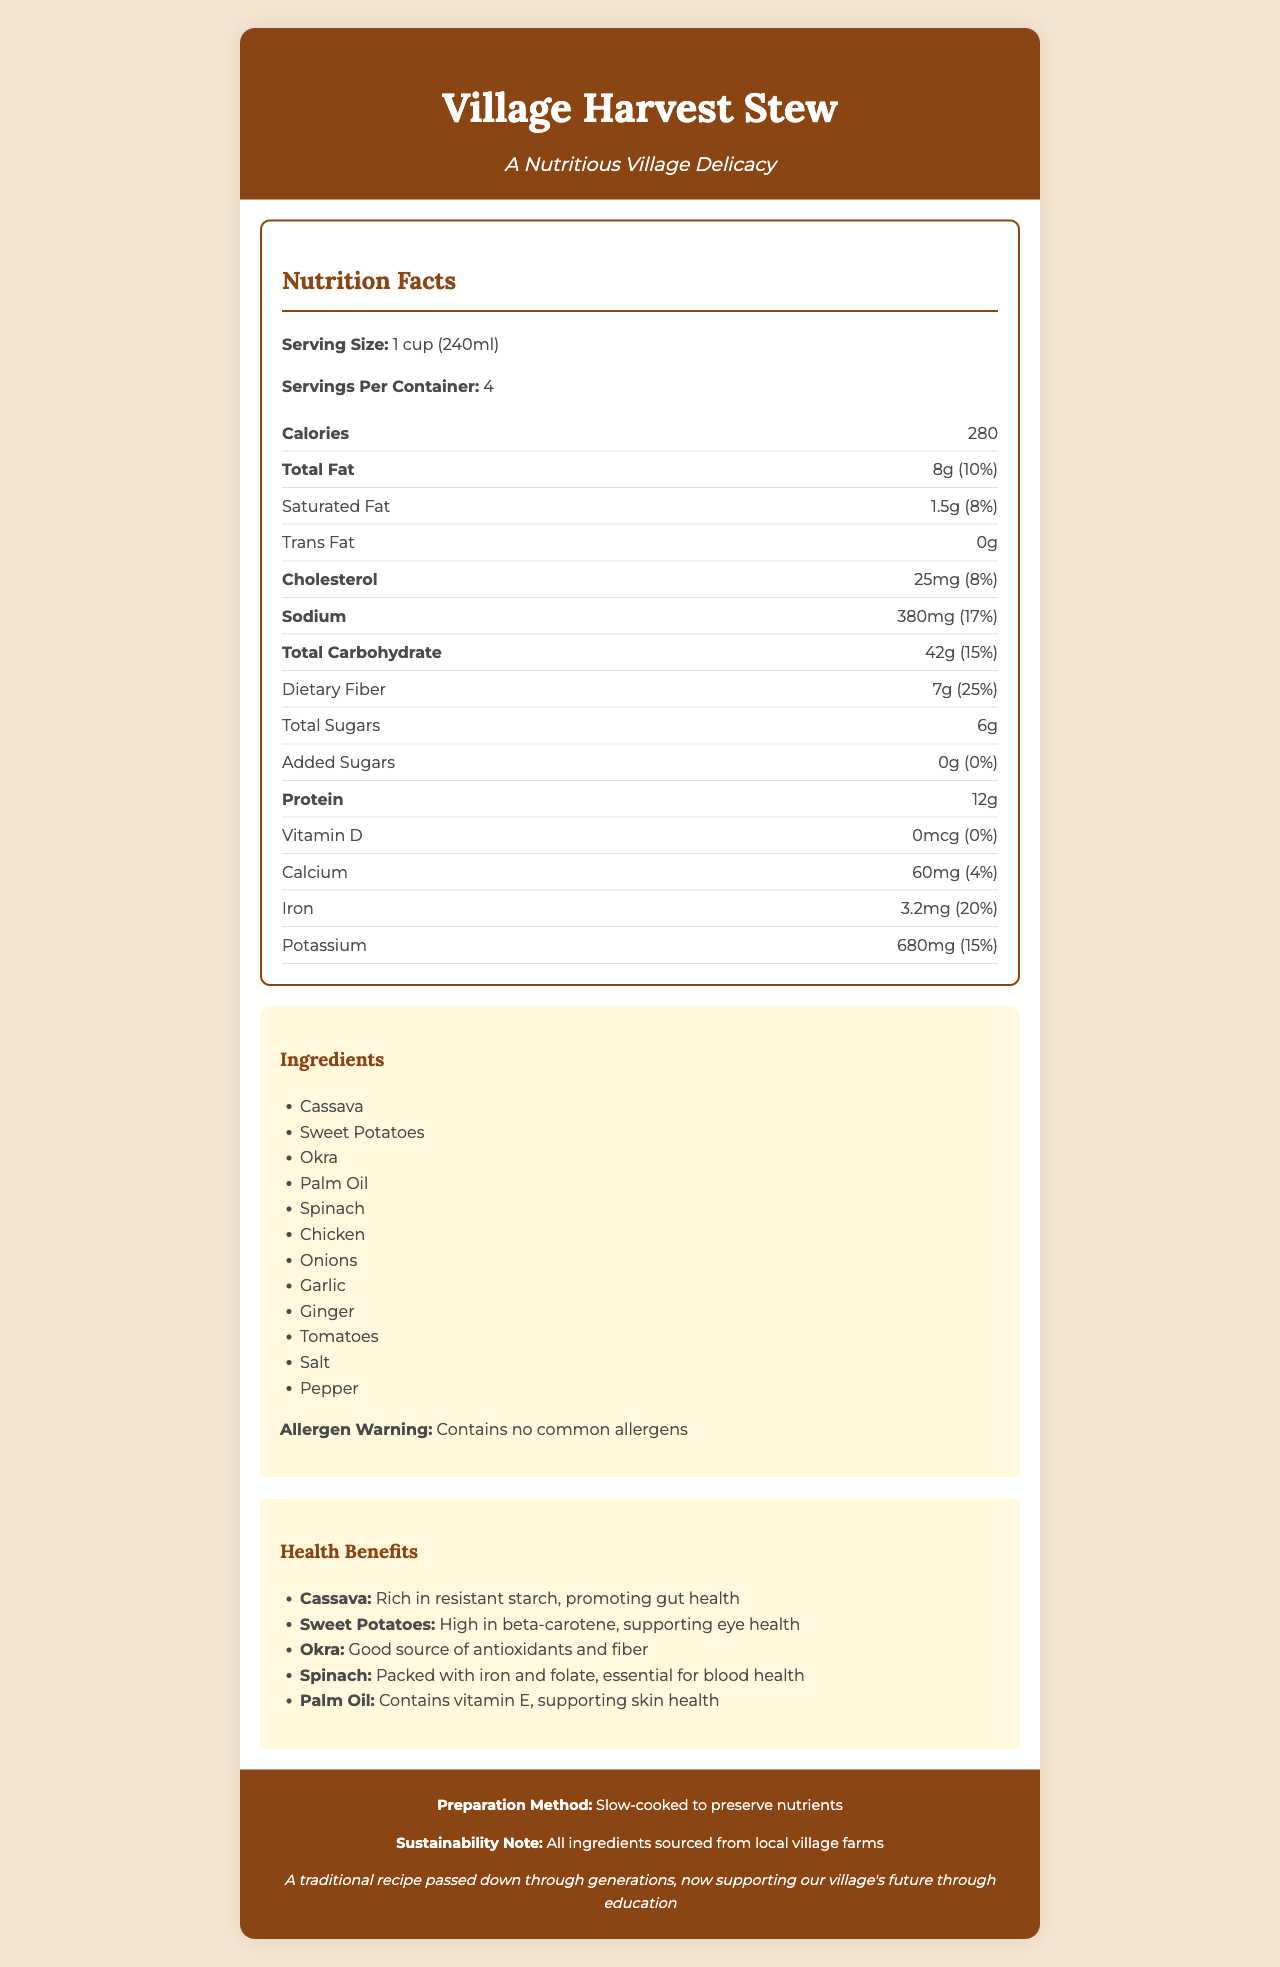what is the serving size? The serving size is explicitly mentioned under the nutrition facts as 1 cup (240ml).
Answer: 1 cup (240ml) how many servings are in one container? The document states that there are 4 servings per container.
Answer: 4 what is the total carbohydrate content per serving? The total carbohydrate content per serving is listed as 42g in the nutrition facts section.
Answer: 42g how much dietary fiber is in one serving? The dietary fiber per serving is given as 7g.
Answer: 7g what are the main ingredients of the Village Harvest Stew? The main ingredients are listed in the ingredients section.
Answer: Cassava, Sweet Potatoes, Okra, Palm Oil, Spinach, Chicken, Onions, Garlic, Ginger, Tomatoes, Salt, Pepper which ingredient in the Village Harvest Stew is high in beta-carotene? A. Spinach B. Cassava C. Sweet Potatoes D. Okra The health benefits section states that sweet potatoes are high in beta-carotene, supporting eye health.
Answer: C. Sweet Potatoes how much iron does one serving provide? The nutrition facts table lists the iron content as 3.2mg per serving.
Answer: 3.2mg does the Village Harvest Stew contain any common allergens? The allergen warning clearly states that it contains no common allergens.
Answer: No how is the Village Harvest Stew prepared? The preparation method indicates that the stew is slow-cooked to preserve nutrients.
Answer: Slow-cooked to preserve nutrients is the vitamin D content in the stew significant? The vitamin D content is 0mcg, which is 0% of the daily value, indicating it is not a significant source of vitamin D.
Answer: No what is the cultural significance of the Village Harvest Stew? The footer explains that the stew is a traditional recipe with cultural significance, now helping support the village's future through education.
Answer: A traditional recipe passed down through generations, now supporting our village's future through education what are the health benefits of cassava in the stew? The health benefits section mentions that cassava is rich in resistant starch which promotes gut health.
Answer: Rich in resistant starch, promoting gut health what is the amount of calcium in one serving? As per the nutrition facts, one serving contains 60mg of calcium.
Answer: 60mg does the Village Harvest Stew include any added sugars? The document states that there are 0g of added sugars in the stew.
Answer: No how many calories are in one serving of the Village Harvest Stew? The nutrition facts section states that there are 280 calories per serving.
Answer: 280 which ingredient is known to contain vitamin E? A. Palm Oil B. Okra C. Tomatoes D. Ginger The health benefits section notes that palm oil contains vitamin E, supporting skin health.
Answer: A. Palm Oil summarize the key nutritional aspects and benefits of the Village Harvest Stew. The nutrition facts and health benefits show that this stew is a healthful, culturally significant meal, prepared using local, sustainable ingredients and helping support the village's future.
Answer: The Village Harvest Stew combines traditional village ingredients such as cassava, sweet potatoes, and okra in a nutritious meal. It provides 280 calories per serving, with considerable amounts of dietary fiber (7g), protein (12g), and iron (3.2mg). The stew is slow-cooked to maintain its nutritional value and offers health benefits promoting gut health, supporting eye health, and supplying essential nutrients like iron and folate. how much saturated fat is there in one serving of Village Harvest Stew? The nutrition facts state that there is 1.5g of saturated fat per serving.
Answer: 1.5g what steps should someone with a peanut allergy take before consuming this stew? The document does not provide specific information about any cross-contamination risks or manufacturing processes related to peanut allergens.
Answer: Not enough information 